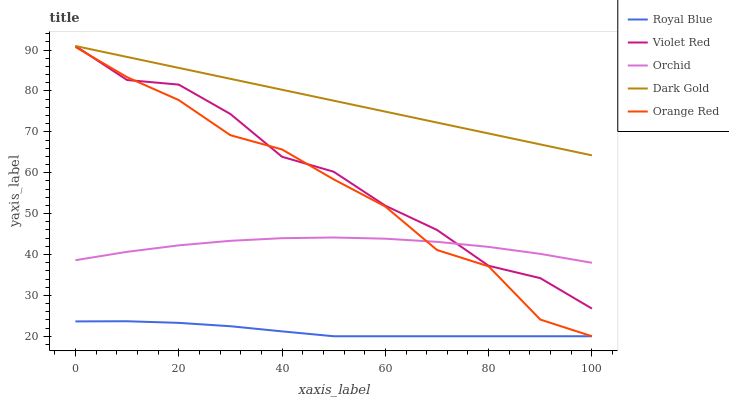Does Royal Blue have the minimum area under the curve?
Answer yes or no. Yes. Does Dark Gold have the maximum area under the curve?
Answer yes or no. Yes. Does Violet Red have the minimum area under the curve?
Answer yes or no. No. Does Violet Red have the maximum area under the curve?
Answer yes or no. No. Is Dark Gold the smoothest?
Answer yes or no. Yes. Is Violet Red the roughest?
Answer yes or no. Yes. Is Violet Red the smoothest?
Answer yes or no. No. Is Dark Gold the roughest?
Answer yes or no. No. Does Royal Blue have the lowest value?
Answer yes or no. Yes. Does Violet Red have the lowest value?
Answer yes or no. No. Does Dark Gold have the highest value?
Answer yes or no. Yes. Does Orange Red have the highest value?
Answer yes or no. No. Is Orange Red less than Dark Gold?
Answer yes or no. Yes. Is Violet Red greater than Royal Blue?
Answer yes or no. Yes. Does Violet Red intersect Orange Red?
Answer yes or no. Yes. Is Violet Red less than Orange Red?
Answer yes or no. No. Is Violet Red greater than Orange Red?
Answer yes or no. No. Does Orange Red intersect Dark Gold?
Answer yes or no. No. 